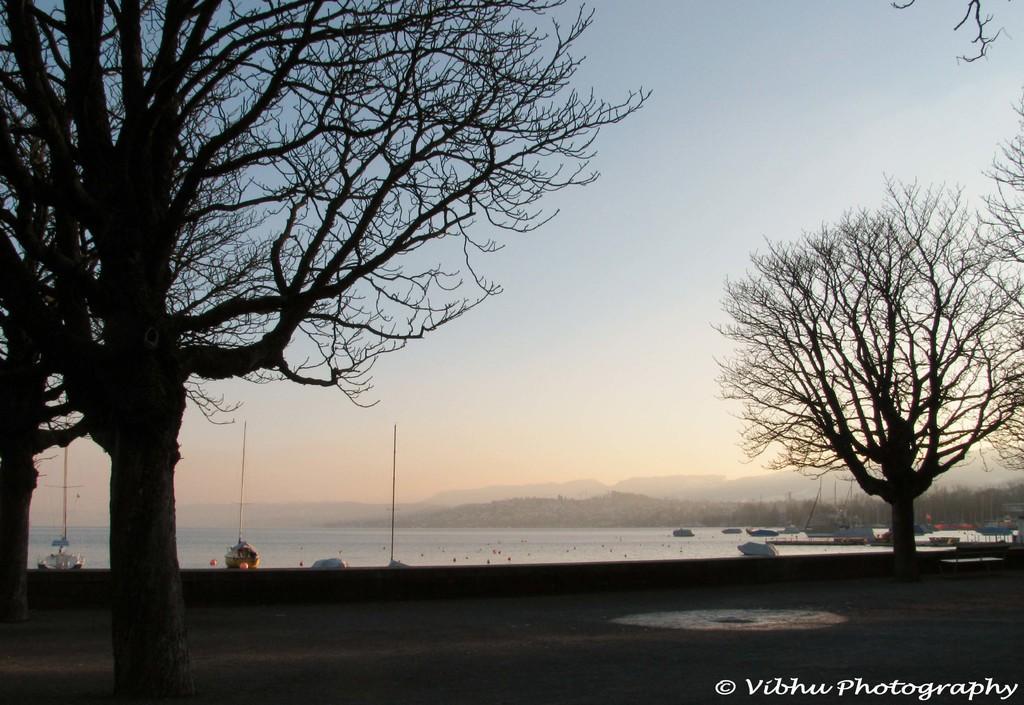Could you give a brief overview of what you see in this image? This picture consists of a road, on the road I can see trees and there is a water, poles, the hill, the sky visible in the middle and there is a text at the bottom. 